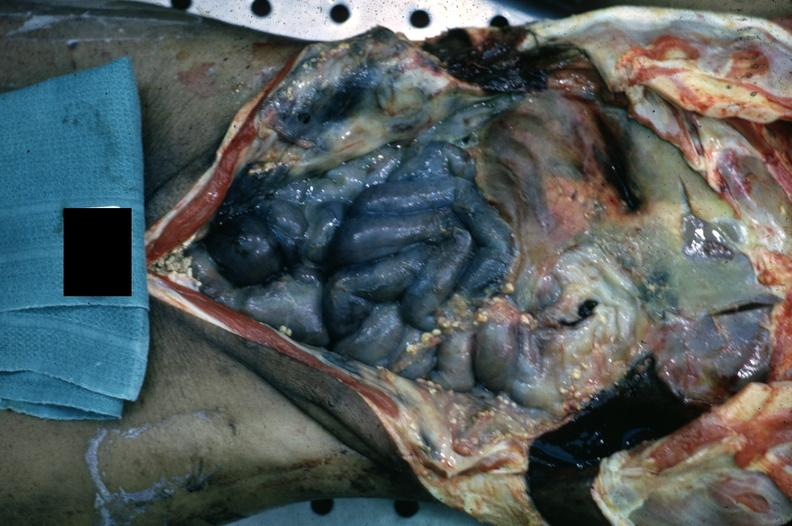does leiomyosarcoma show opened body cavity with necrotic bowel and heavy fibrin exudate?
Answer the question using a single word or phrase. No 